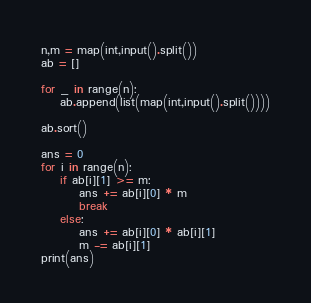Convert code to text. <code><loc_0><loc_0><loc_500><loc_500><_Python_>n,m = map(int,input().split())
ab = []

for _ in range(n):
	ab.append(list(map(int,input().split())))

ab.sort()

ans = 0
for i in range(n):
	if ab[i][1] >= m:
		ans += ab[i][0] * m
		break
	else:
		ans += ab[i][0] * ab[i][1]
		m -= ab[i][1]
print(ans)
</code> 